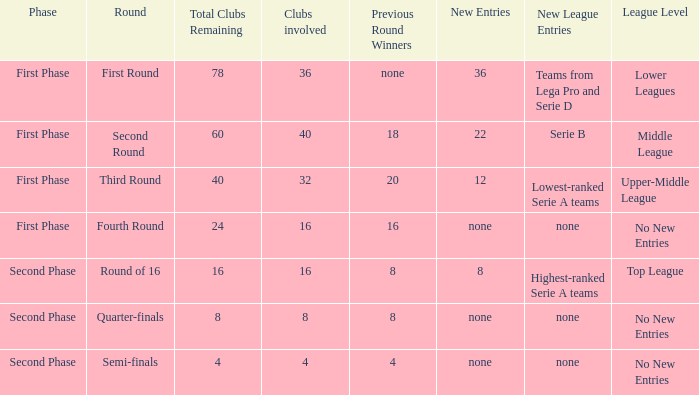When looking at new entries this round and seeing 8; what number in total is there for clubs remaining? 1.0. 